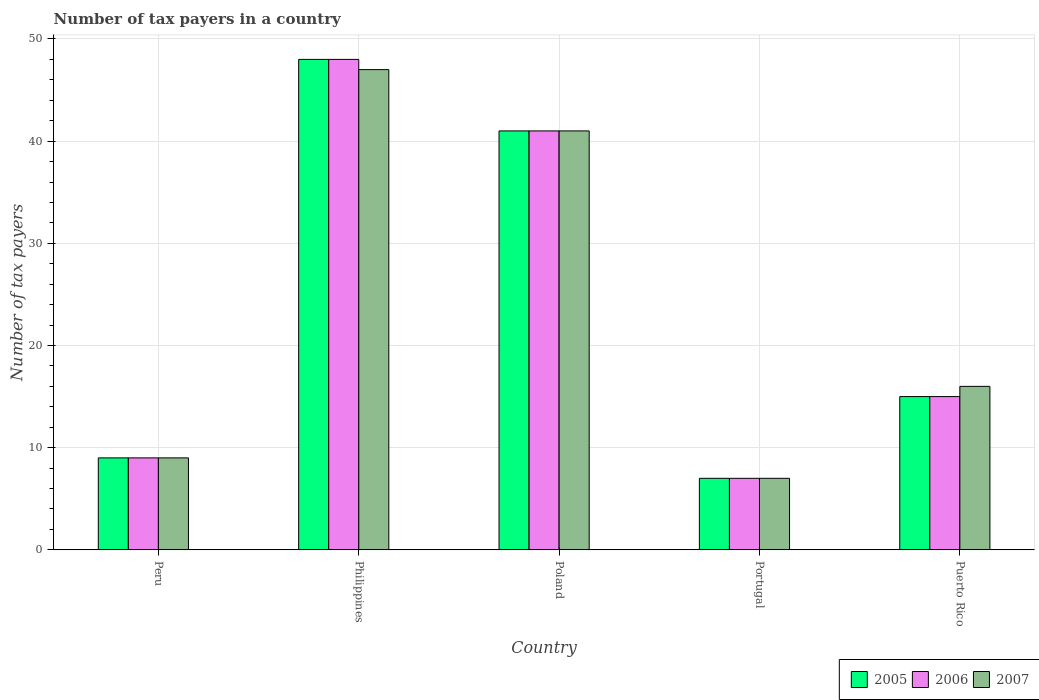How many different coloured bars are there?
Offer a terse response. 3. How many groups of bars are there?
Ensure brevity in your answer.  5. Are the number of bars on each tick of the X-axis equal?
Ensure brevity in your answer.  Yes. How many bars are there on the 2nd tick from the left?
Your answer should be very brief. 3. How many bars are there on the 1st tick from the right?
Provide a succinct answer. 3. What is the label of the 5th group of bars from the left?
Your answer should be very brief. Puerto Rico. Across all countries, what is the maximum number of tax payers in in 2006?
Ensure brevity in your answer.  48. In which country was the number of tax payers in in 2005 maximum?
Offer a terse response. Philippines. What is the total number of tax payers in in 2005 in the graph?
Your response must be concise. 120. What is the difference between the number of tax payers in in 2007 in Philippines and that in Puerto Rico?
Offer a very short reply. 31. What is the difference between the number of tax payers in in 2005 in Philippines and the number of tax payers in in 2007 in Poland?
Your answer should be compact. 7. What is the ratio of the number of tax payers in in 2006 in Peru to that in Poland?
Your answer should be compact. 0.22. Is the difference between the number of tax payers in in 2005 in Poland and Puerto Rico greater than the difference between the number of tax payers in in 2006 in Poland and Puerto Rico?
Offer a very short reply. No. In how many countries, is the number of tax payers in in 2007 greater than the average number of tax payers in in 2007 taken over all countries?
Offer a terse response. 2. What does the 1st bar from the left in Poland represents?
Your response must be concise. 2005. Are all the bars in the graph horizontal?
Your answer should be compact. No. How many countries are there in the graph?
Keep it short and to the point. 5. What is the difference between two consecutive major ticks on the Y-axis?
Offer a terse response. 10. Does the graph contain any zero values?
Provide a short and direct response. No. Does the graph contain grids?
Ensure brevity in your answer.  Yes. How many legend labels are there?
Make the answer very short. 3. What is the title of the graph?
Make the answer very short. Number of tax payers in a country. What is the label or title of the X-axis?
Provide a succinct answer. Country. What is the label or title of the Y-axis?
Provide a succinct answer. Number of tax payers. What is the Number of tax payers in 2007 in Peru?
Your answer should be compact. 9. What is the Number of tax payers of 2006 in Philippines?
Your answer should be compact. 48. What is the Number of tax payers in 2007 in Philippines?
Your response must be concise. 47. What is the Number of tax payers of 2007 in Poland?
Offer a very short reply. 41. What is the Number of tax payers of 2005 in Portugal?
Keep it short and to the point. 7. What is the Number of tax payers in 2006 in Portugal?
Your answer should be compact. 7. What is the Number of tax payers of 2007 in Portugal?
Your answer should be compact. 7. What is the Number of tax payers in 2005 in Puerto Rico?
Your answer should be compact. 15. What is the Number of tax payers of 2006 in Puerto Rico?
Give a very brief answer. 15. What is the Number of tax payers in 2007 in Puerto Rico?
Provide a succinct answer. 16. Across all countries, what is the maximum Number of tax payers of 2005?
Give a very brief answer. 48. Across all countries, what is the maximum Number of tax payers in 2006?
Offer a very short reply. 48. Across all countries, what is the minimum Number of tax payers in 2007?
Your answer should be compact. 7. What is the total Number of tax payers of 2005 in the graph?
Your answer should be very brief. 120. What is the total Number of tax payers in 2006 in the graph?
Provide a succinct answer. 120. What is the total Number of tax payers of 2007 in the graph?
Your answer should be compact. 120. What is the difference between the Number of tax payers of 2005 in Peru and that in Philippines?
Make the answer very short. -39. What is the difference between the Number of tax payers of 2006 in Peru and that in Philippines?
Keep it short and to the point. -39. What is the difference between the Number of tax payers of 2007 in Peru and that in Philippines?
Make the answer very short. -38. What is the difference between the Number of tax payers in 2005 in Peru and that in Poland?
Your response must be concise. -32. What is the difference between the Number of tax payers of 2006 in Peru and that in Poland?
Your answer should be compact. -32. What is the difference between the Number of tax payers of 2007 in Peru and that in Poland?
Provide a short and direct response. -32. What is the difference between the Number of tax payers in 2006 in Peru and that in Portugal?
Provide a succinct answer. 2. What is the difference between the Number of tax payers of 2007 in Peru and that in Portugal?
Make the answer very short. 2. What is the difference between the Number of tax payers in 2006 in Peru and that in Puerto Rico?
Ensure brevity in your answer.  -6. What is the difference between the Number of tax payers of 2007 in Peru and that in Puerto Rico?
Your answer should be very brief. -7. What is the difference between the Number of tax payers of 2007 in Philippines and that in Poland?
Your response must be concise. 6. What is the difference between the Number of tax payers in 2005 in Philippines and that in Portugal?
Provide a short and direct response. 41. What is the difference between the Number of tax payers in 2005 in Philippines and that in Puerto Rico?
Your answer should be compact. 33. What is the difference between the Number of tax payers of 2006 in Philippines and that in Puerto Rico?
Provide a succinct answer. 33. What is the difference between the Number of tax payers of 2007 in Philippines and that in Puerto Rico?
Offer a very short reply. 31. What is the difference between the Number of tax payers of 2005 in Poland and that in Portugal?
Ensure brevity in your answer.  34. What is the difference between the Number of tax payers of 2007 in Poland and that in Portugal?
Your answer should be very brief. 34. What is the difference between the Number of tax payers of 2007 in Poland and that in Puerto Rico?
Your response must be concise. 25. What is the difference between the Number of tax payers of 2005 in Portugal and that in Puerto Rico?
Make the answer very short. -8. What is the difference between the Number of tax payers of 2006 in Portugal and that in Puerto Rico?
Offer a very short reply. -8. What is the difference between the Number of tax payers in 2007 in Portugal and that in Puerto Rico?
Offer a very short reply. -9. What is the difference between the Number of tax payers of 2005 in Peru and the Number of tax payers of 2006 in Philippines?
Provide a short and direct response. -39. What is the difference between the Number of tax payers of 2005 in Peru and the Number of tax payers of 2007 in Philippines?
Provide a short and direct response. -38. What is the difference between the Number of tax payers of 2006 in Peru and the Number of tax payers of 2007 in Philippines?
Ensure brevity in your answer.  -38. What is the difference between the Number of tax payers of 2005 in Peru and the Number of tax payers of 2006 in Poland?
Make the answer very short. -32. What is the difference between the Number of tax payers in 2005 in Peru and the Number of tax payers in 2007 in Poland?
Your answer should be very brief. -32. What is the difference between the Number of tax payers of 2006 in Peru and the Number of tax payers of 2007 in Poland?
Make the answer very short. -32. What is the difference between the Number of tax payers of 2005 in Peru and the Number of tax payers of 2007 in Puerto Rico?
Your answer should be compact. -7. What is the difference between the Number of tax payers in 2006 in Peru and the Number of tax payers in 2007 in Puerto Rico?
Provide a succinct answer. -7. What is the difference between the Number of tax payers of 2005 in Philippines and the Number of tax payers of 2007 in Poland?
Provide a succinct answer. 7. What is the difference between the Number of tax payers in 2005 in Philippines and the Number of tax payers in 2006 in Portugal?
Give a very brief answer. 41. What is the difference between the Number of tax payers of 2006 in Philippines and the Number of tax payers of 2007 in Portugal?
Ensure brevity in your answer.  41. What is the difference between the Number of tax payers of 2005 in Philippines and the Number of tax payers of 2007 in Puerto Rico?
Keep it short and to the point. 32. What is the difference between the Number of tax payers of 2005 in Poland and the Number of tax payers of 2006 in Portugal?
Offer a terse response. 34. What is the difference between the Number of tax payers in 2006 in Poland and the Number of tax payers in 2007 in Portugal?
Provide a short and direct response. 34. What is the difference between the Number of tax payers in 2005 in Poland and the Number of tax payers in 2006 in Puerto Rico?
Give a very brief answer. 26. What is the difference between the Number of tax payers of 2006 in Poland and the Number of tax payers of 2007 in Puerto Rico?
Offer a very short reply. 25. What is the average Number of tax payers of 2005 per country?
Your response must be concise. 24. What is the difference between the Number of tax payers in 2005 and Number of tax payers in 2007 in Peru?
Your response must be concise. 0. What is the difference between the Number of tax payers of 2005 and Number of tax payers of 2006 in Philippines?
Ensure brevity in your answer.  0. What is the difference between the Number of tax payers in 2006 and Number of tax payers in 2007 in Philippines?
Provide a short and direct response. 1. What is the difference between the Number of tax payers of 2006 and Number of tax payers of 2007 in Portugal?
Offer a very short reply. 0. What is the difference between the Number of tax payers of 2005 and Number of tax payers of 2006 in Puerto Rico?
Ensure brevity in your answer.  0. What is the ratio of the Number of tax payers in 2005 in Peru to that in Philippines?
Provide a succinct answer. 0.19. What is the ratio of the Number of tax payers in 2006 in Peru to that in Philippines?
Your answer should be very brief. 0.19. What is the ratio of the Number of tax payers in 2007 in Peru to that in Philippines?
Give a very brief answer. 0.19. What is the ratio of the Number of tax payers of 2005 in Peru to that in Poland?
Offer a terse response. 0.22. What is the ratio of the Number of tax payers of 2006 in Peru to that in Poland?
Keep it short and to the point. 0.22. What is the ratio of the Number of tax payers in 2007 in Peru to that in Poland?
Offer a very short reply. 0.22. What is the ratio of the Number of tax payers in 2005 in Peru to that in Portugal?
Your answer should be very brief. 1.29. What is the ratio of the Number of tax payers in 2007 in Peru to that in Portugal?
Keep it short and to the point. 1.29. What is the ratio of the Number of tax payers of 2006 in Peru to that in Puerto Rico?
Ensure brevity in your answer.  0.6. What is the ratio of the Number of tax payers in 2007 in Peru to that in Puerto Rico?
Your answer should be very brief. 0.56. What is the ratio of the Number of tax payers in 2005 in Philippines to that in Poland?
Offer a terse response. 1.17. What is the ratio of the Number of tax payers in 2006 in Philippines to that in Poland?
Your answer should be compact. 1.17. What is the ratio of the Number of tax payers in 2007 in Philippines to that in Poland?
Ensure brevity in your answer.  1.15. What is the ratio of the Number of tax payers in 2005 in Philippines to that in Portugal?
Your response must be concise. 6.86. What is the ratio of the Number of tax payers of 2006 in Philippines to that in Portugal?
Make the answer very short. 6.86. What is the ratio of the Number of tax payers of 2007 in Philippines to that in Portugal?
Offer a very short reply. 6.71. What is the ratio of the Number of tax payers in 2006 in Philippines to that in Puerto Rico?
Ensure brevity in your answer.  3.2. What is the ratio of the Number of tax payers in 2007 in Philippines to that in Puerto Rico?
Your answer should be compact. 2.94. What is the ratio of the Number of tax payers in 2005 in Poland to that in Portugal?
Provide a short and direct response. 5.86. What is the ratio of the Number of tax payers of 2006 in Poland to that in Portugal?
Your answer should be very brief. 5.86. What is the ratio of the Number of tax payers of 2007 in Poland to that in Portugal?
Give a very brief answer. 5.86. What is the ratio of the Number of tax payers in 2005 in Poland to that in Puerto Rico?
Provide a succinct answer. 2.73. What is the ratio of the Number of tax payers in 2006 in Poland to that in Puerto Rico?
Your response must be concise. 2.73. What is the ratio of the Number of tax payers of 2007 in Poland to that in Puerto Rico?
Your response must be concise. 2.56. What is the ratio of the Number of tax payers of 2005 in Portugal to that in Puerto Rico?
Offer a terse response. 0.47. What is the ratio of the Number of tax payers of 2006 in Portugal to that in Puerto Rico?
Your answer should be very brief. 0.47. What is the ratio of the Number of tax payers of 2007 in Portugal to that in Puerto Rico?
Provide a short and direct response. 0.44. What is the difference between the highest and the lowest Number of tax payers of 2005?
Offer a very short reply. 41. What is the difference between the highest and the lowest Number of tax payers in 2006?
Keep it short and to the point. 41. 